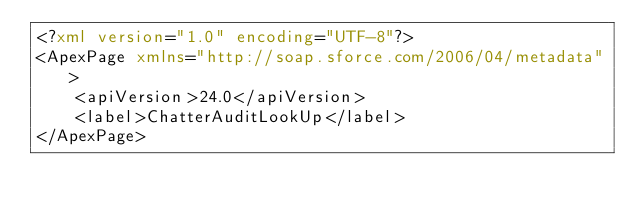<code> <loc_0><loc_0><loc_500><loc_500><_XML_><?xml version="1.0" encoding="UTF-8"?>
<ApexPage xmlns="http://soap.sforce.com/2006/04/metadata">
    <apiVersion>24.0</apiVersion>
    <label>ChatterAuditLookUp</label>
</ApexPage>
</code> 